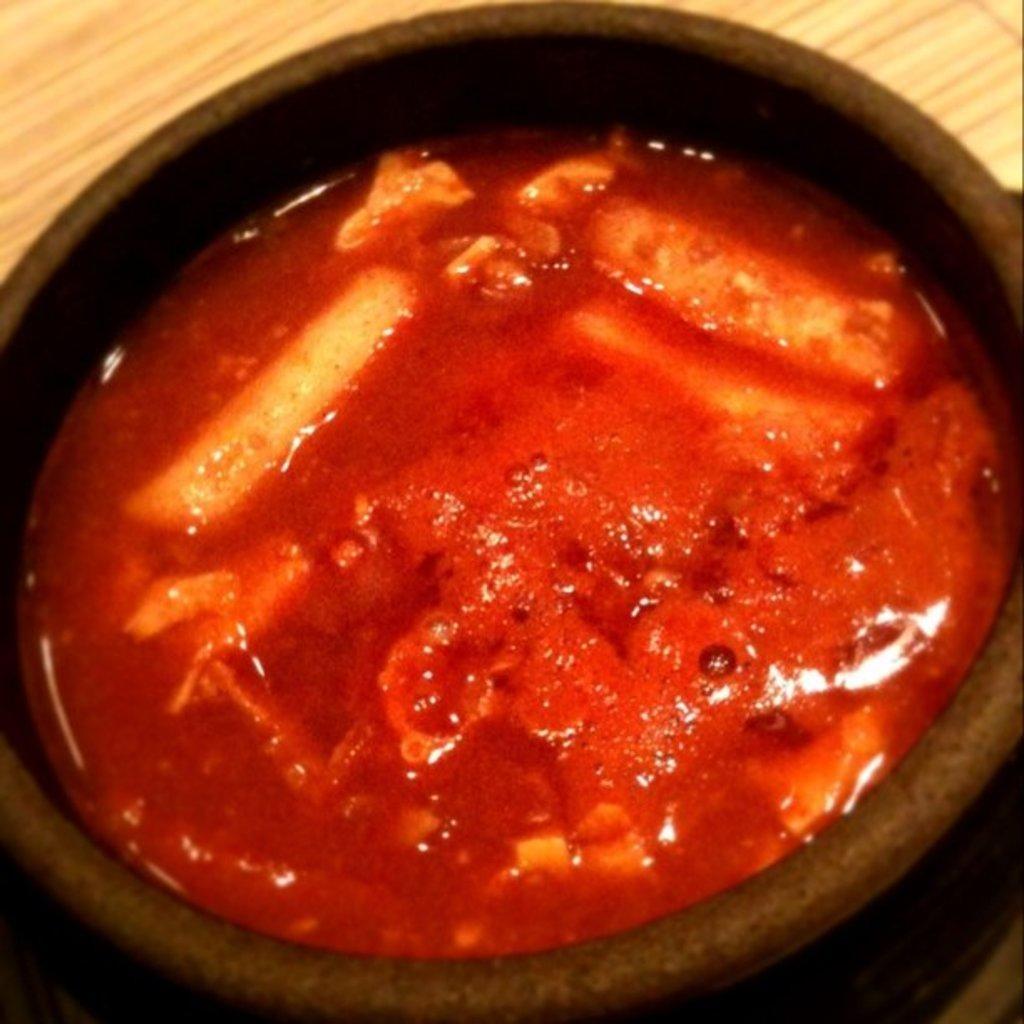How would you summarize this image in a sentence or two? This image consists of a bowl. In that there is something like a soup. It is in red color. 